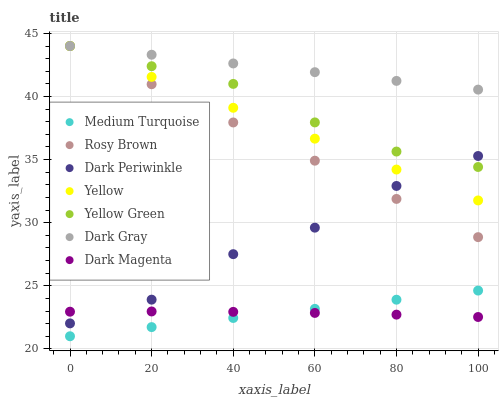Does Medium Turquoise have the minimum area under the curve?
Answer yes or no. Yes. Does Dark Gray have the maximum area under the curve?
Answer yes or no. Yes. Does Rosy Brown have the minimum area under the curve?
Answer yes or no. No. Does Rosy Brown have the maximum area under the curve?
Answer yes or no. No. Is Medium Turquoise the smoothest?
Answer yes or no. Yes. Is Dark Periwinkle the roughest?
Answer yes or no. Yes. Is Rosy Brown the smoothest?
Answer yes or no. No. Is Rosy Brown the roughest?
Answer yes or no. No. Does Medium Turquoise have the lowest value?
Answer yes or no. Yes. Does Rosy Brown have the lowest value?
Answer yes or no. No. Does Dark Gray have the highest value?
Answer yes or no. Yes. Does Medium Turquoise have the highest value?
Answer yes or no. No. Is Medium Turquoise less than Rosy Brown?
Answer yes or no. Yes. Is Rosy Brown greater than Dark Magenta?
Answer yes or no. Yes. Does Dark Gray intersect Yellow?
Answer yes or no. Yes. Is Dark Gray less than Yellow?
Answer yes or no. No. Is Dark Gray greater than Yellow?
Answer yes or no. No. Does Medium Turquoise intersect Rosy Brown?
Answer yes or no. No. 